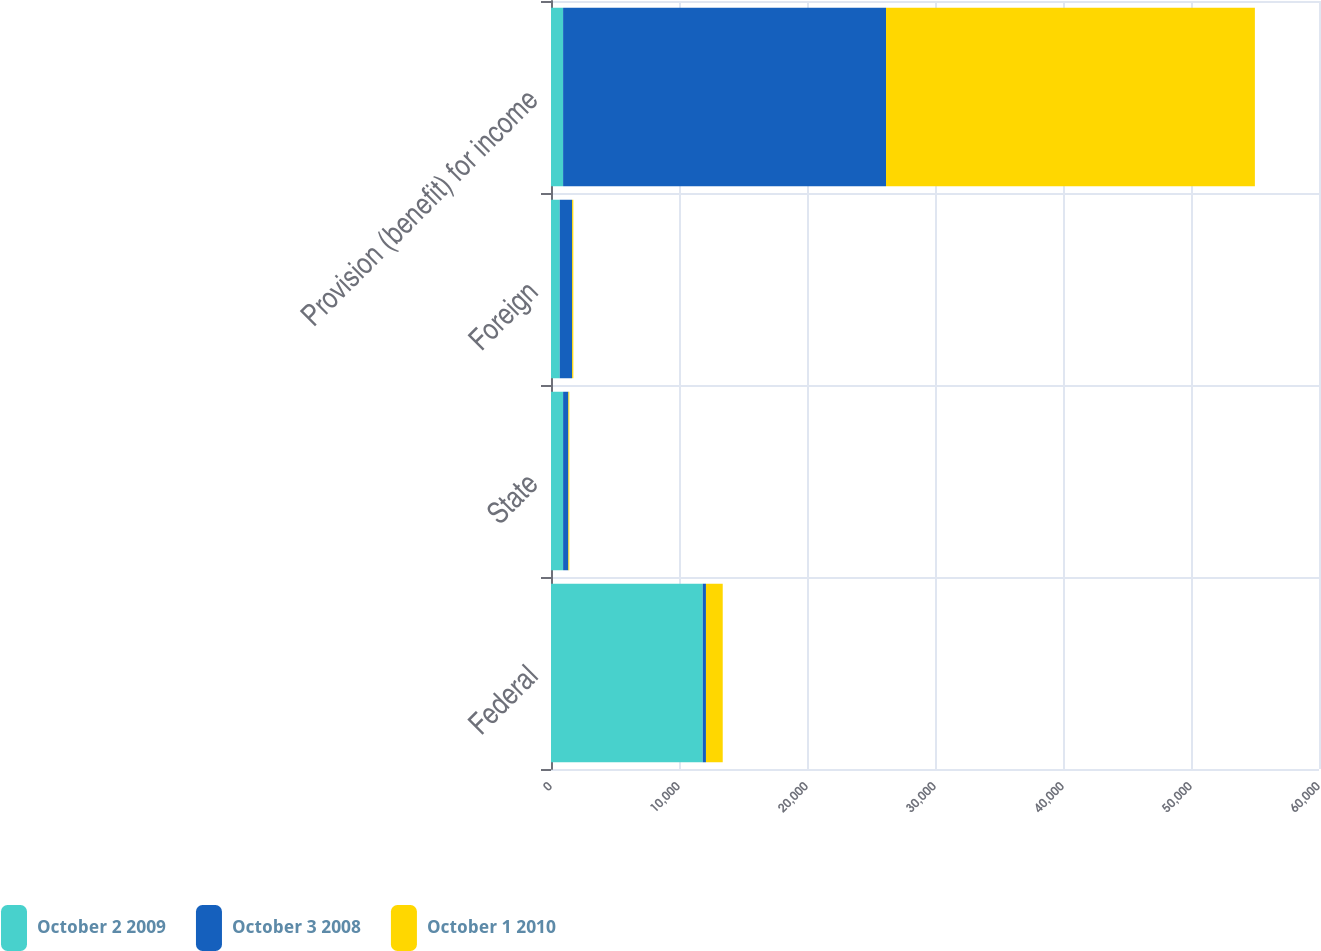Convert chart. <chart><loc_0><loc_0><loc_500><loc_500><stacked_bar_chart><ecel><fcel>Federal<fcel>State<fcel>Foreign<fcel>Provision (benefit) for income<nl><fcel>October 2 2009<fcel>11855<fcel>946<fcel>684<fcel>946<nl><fcel>October 3 2008<fcel>251<fcel>413<fcel>966<fcel>25227<nl><fcel>October 1 2010<fcel>1310<fcel>72<fcel>94<fcel>28818<nl></chart> 